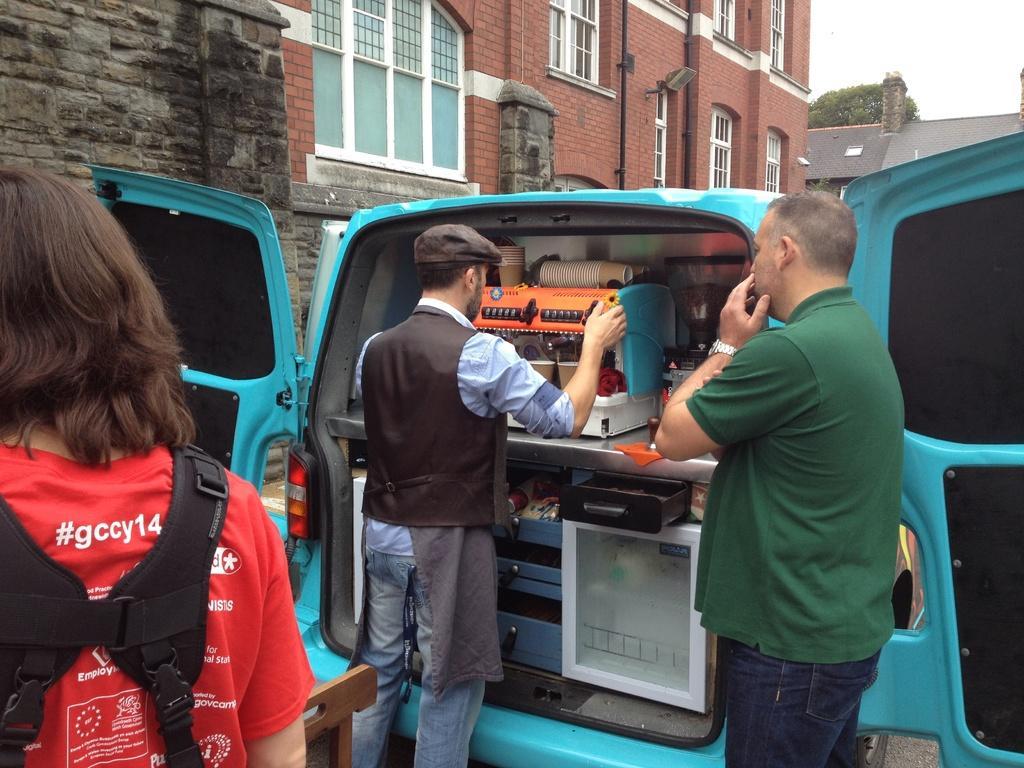In one or two sentences, can you explain what this image depicts? In this image we can see three persons standing and there is a vehicle in which we can see the paper cups and also a machine. In the background we can see the buildings and also the tree. Sky is also visible. 